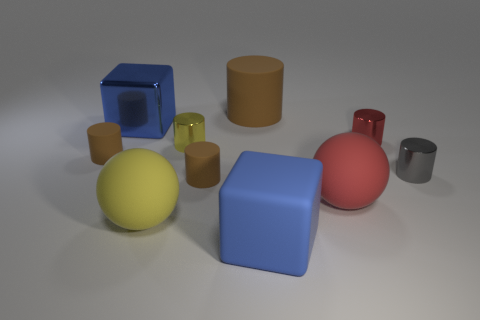How many balls are blue things or red matte things?
Offer a very short reply. 1. Is the number of big balls in front of the blue rubber object less than the number of metal cylinders?
Make the answer very short. Yes. There is a yellow thing that is the same material as the red sphere; what is its shape?
Ensure brevity in your answer.  Sphere. How many matte cylinders have the same color as the big matte block?
Your response must be concise. 0. How many things are large brown rubber objects or small yellow shiny cylinders?
Provide a short and direct response. 2. The large object that is behind the blue object that is behind the yellow cylinder is made of what material?
Offer a terse response. Rubber. Is there a purple cylinder that has the same material as the large brown cylinder?
Your answer should be very brief. No. What shape is the blue thing that is behind the matte thing on the left side of the metal thing left of the small yellow object?
Ensure brevity in your answer.  Cube. What material is the small yellow cylinder?
Your answer should be very brief. Metal. There is a big cube that is the same material as the red cylinder; what is its color?
Ensure brevity in your answer.  Blue. 